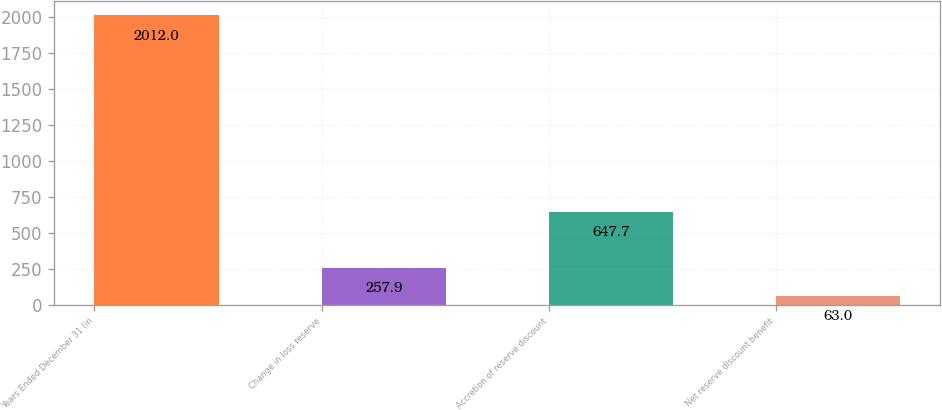<chart> <loc_0><loc_0><loc_500><loc_500><bar_chart><fcel>Years Ended December 31 (in<fcel>Change in loss reserve<fcel>Accretion of reserve discount<fcel>Net reserve discount benefit<nl><fcel>2012<fcel>257.9<fcel>647.7<fcel>63<nl></chart> 